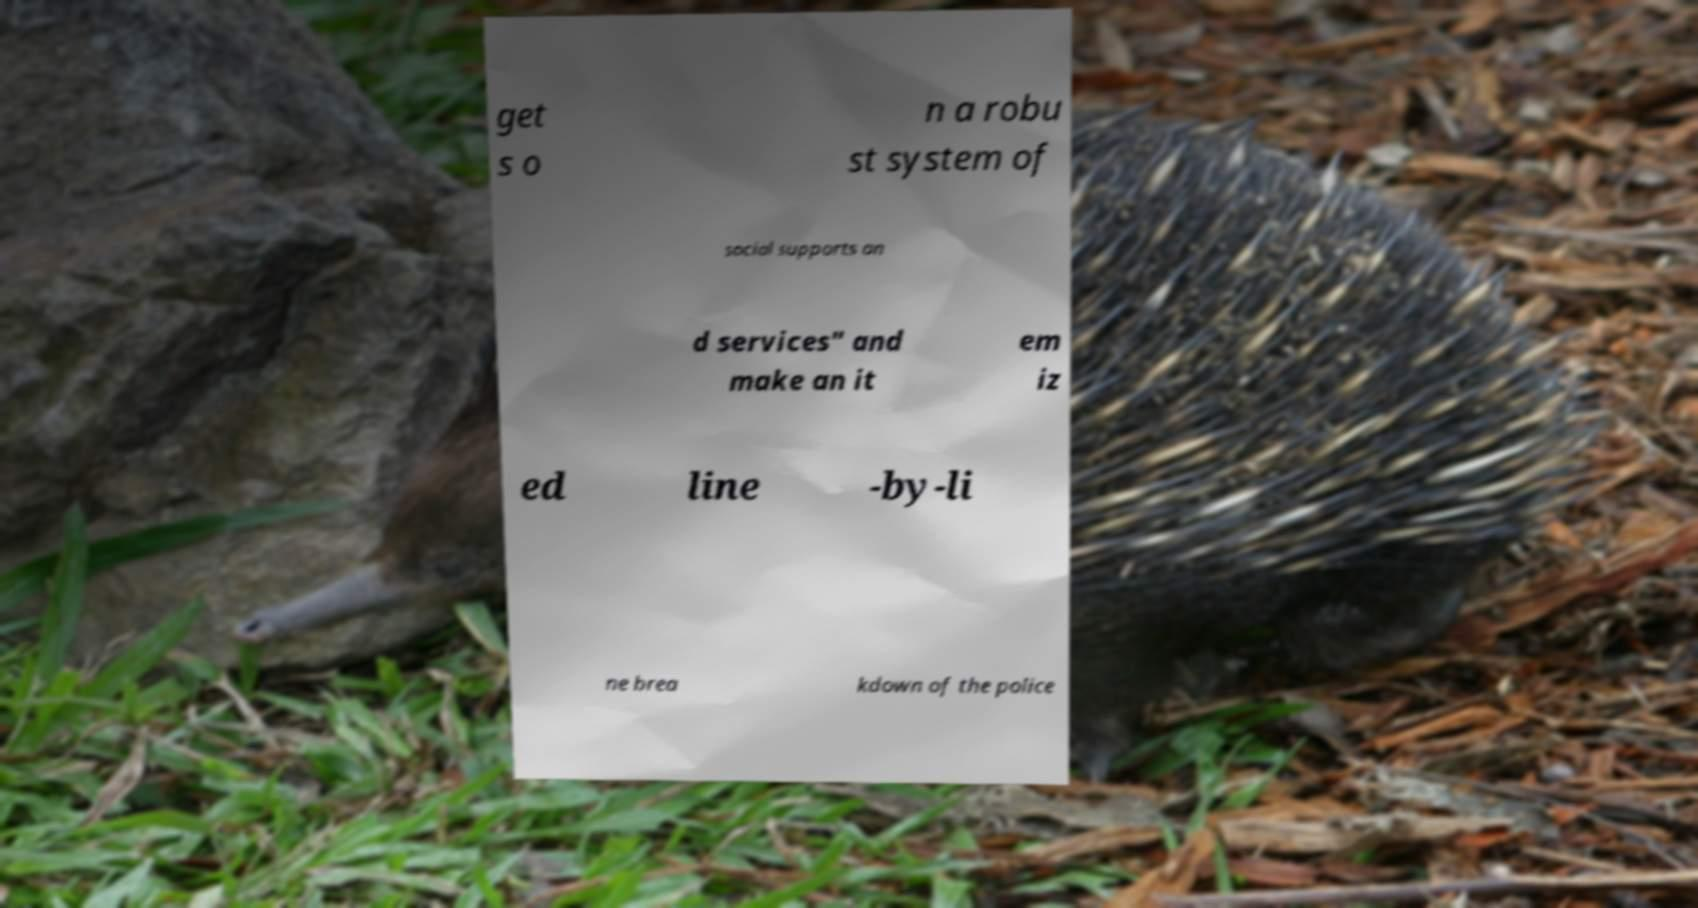I need the written content from this picture converted into text. Can you do that? get s o n a robu st system of social supports an d services" and make an it em iz ed line -by-li ne brea kdown of the police 